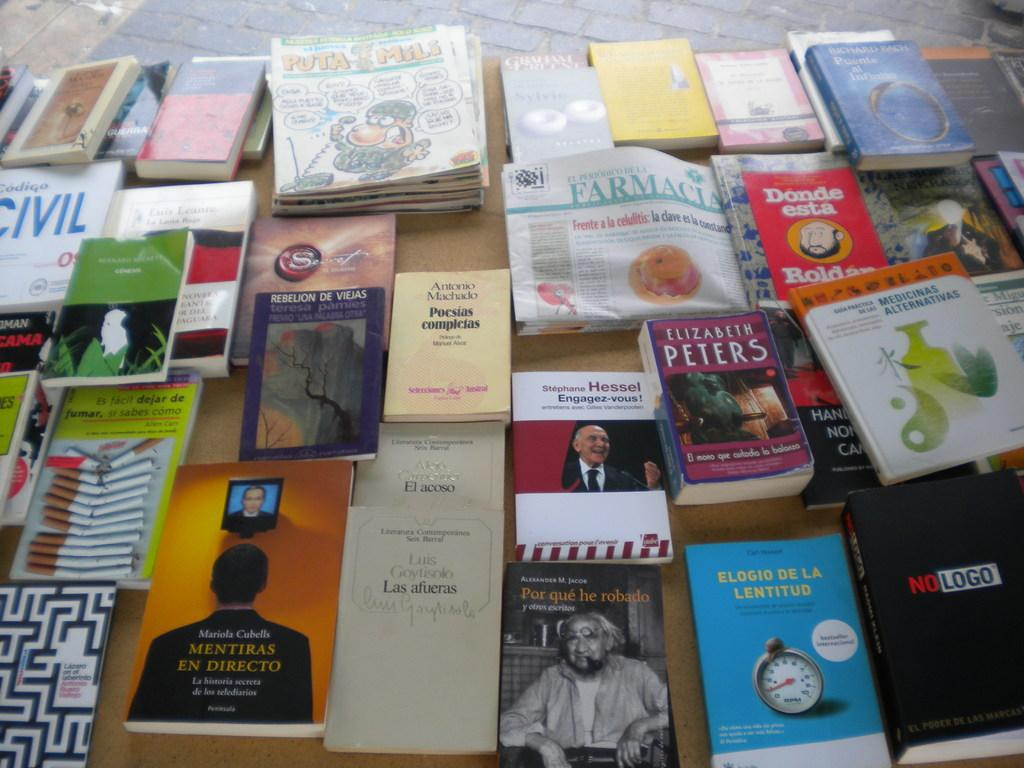What objects are on the table in the foreground of the image? There are books and newspapers on a table in the foreground of the image. Can you describe the floor visible in the image? The floor is visible at the top of the image. What type of brick pattern can be seen on the floor in the image? There is no brick pattern visible on the floor in the image; only the floor itself is mentioned. What kind of writing is present on the newspapers in the image? The content of the newspapers is not visible in the image, so it is not possible to determine the type of writing present. 